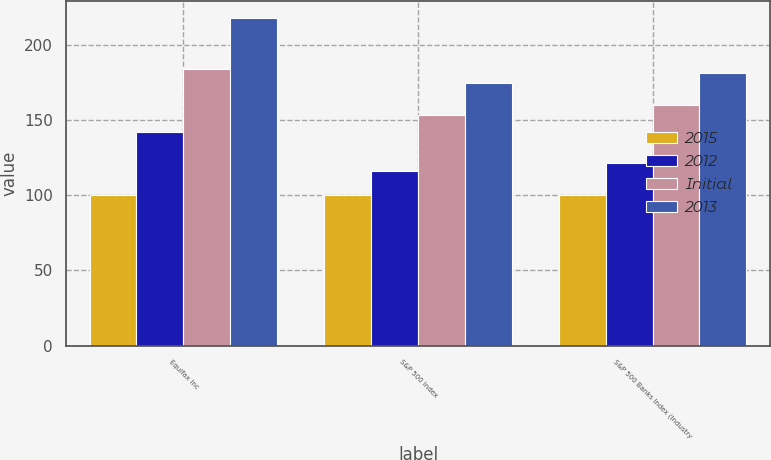<chart> <loc_0><loc_0><loc_500><loc_500><stacked_bar_chart><ecel><fcel>Equifax Inc<fcel>S&P 500 Index<fcel>S&P 500 Banks Index (Industry<nl><fcel>2015<fcel>100<fcel>100<fcel>100<nl><fcel>2012<fcel>141.91<fcel>116<fcel>121.19<nl><fcel>Initial<fcel>183.8<fcel>153.57<fcel>160.27<nl><fcel>2013<fcel>218.08<fcel>174.59<fcel>181.52<nl></chart> 